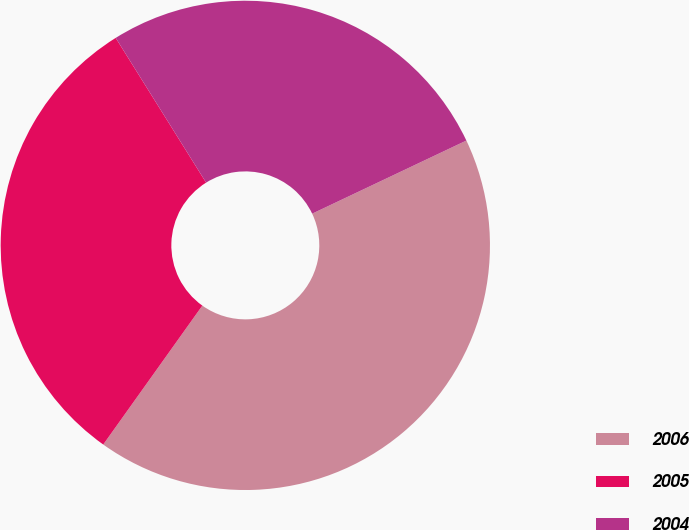Convert chart. <chart><loc_0><loc_0><loc_500><loc_500><pie_chart><fcel>2006<fcel>2005<fcel>2004<nl><fcel>41.91%<fcel>31.25%<fcel>26.84%<nl></chart> 